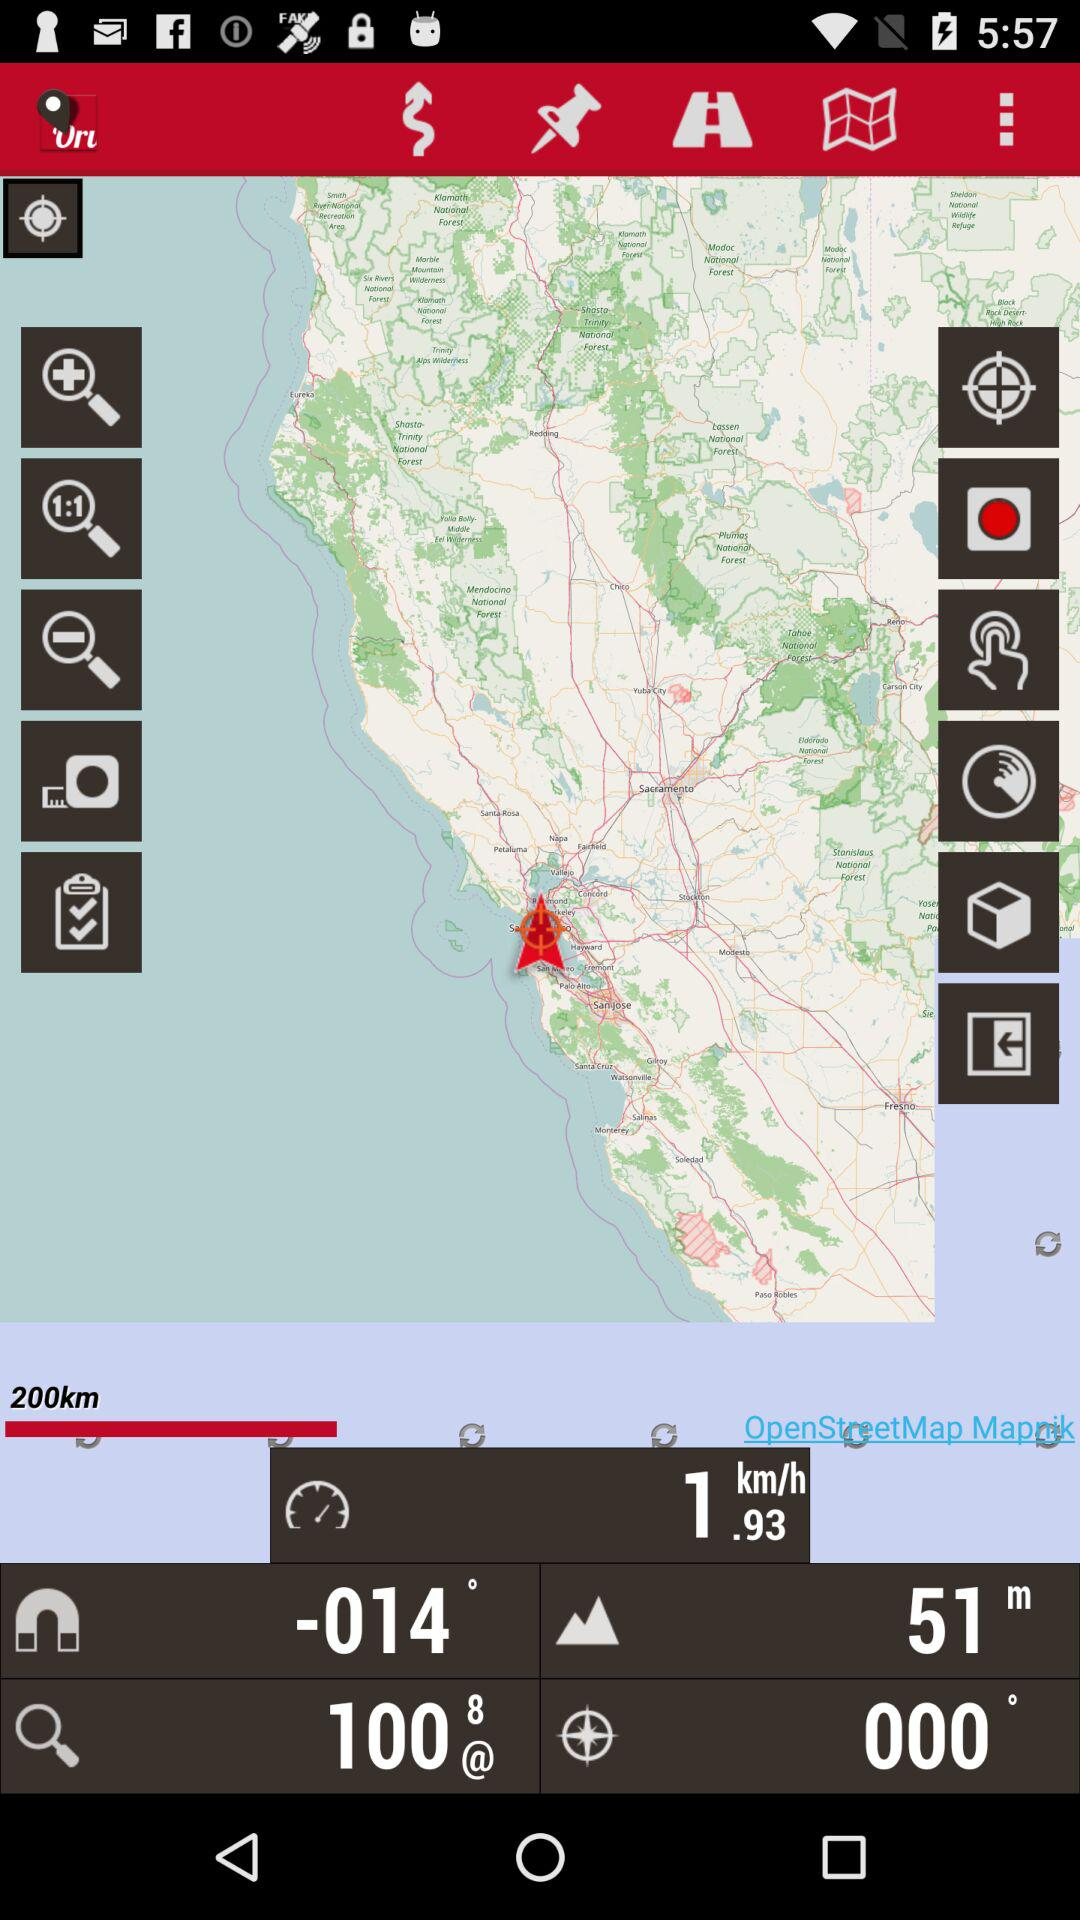Can you inform me about the major cities close to this marker? The marker is located near San Francisco, San Jose, and Oakland. These major cities are key cultural, economic, and transportation hubs in California. 